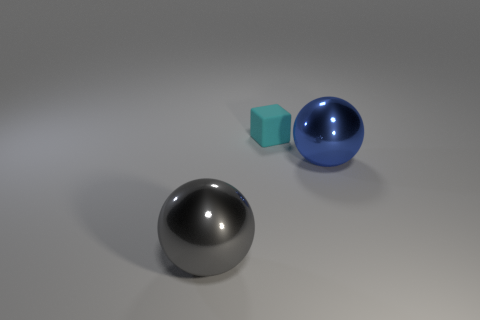Is there anything else that is made of the same material as the tiny thing?
Provide a short and direct response. No. What is the material of the object that is to the left of the big blue metallic thing and on the right side of the gray metallic thing?
Give a very brief answer. Rubber. What number of objects are big spheres that are behind the gray shiny ball or large rubber blocks?
Give a very brief answer. 1. Are there any other metal spheres of the same size as the gray metal sphere?
Give a very brief answer. Yes. What number of things are both on the left side of the blue metallic ball and behind the gray shiny sphere?
Provide a succinct answer. 1. There is a gray shiny object; how many rubber objects are to the right of it?
Provide a succinct answer. 1. Are there any other metallic objects of the same shape as the large gray metallic thing?
Keep it short and to the point. Yes. Does the cyan rubber object have the same shape as the shiny object on the right side of the gray shiny ball?
Provide a succinct answer. No. How many cubes are tiny cyan things or gray objects?
Ensure brevity in your answer.  1. There is a big metallic object behind the gray metallic object; what shape is it?
Give a very brief answer. Sphere. 